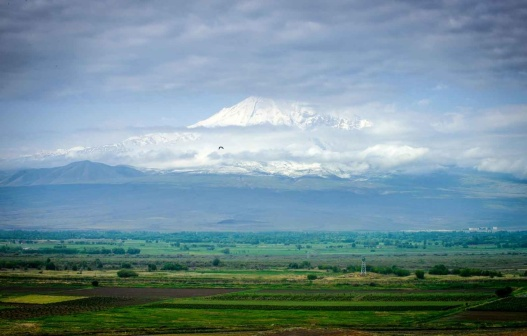How might this landscape change with the seasons? In spring, the snow on the mountain's peak begins to melt, feeding the valley with streams of fresh water, causing the fields to burst into a riot of colorful wildflowers. Summer brings a lush green carpet to the valley, with longer days and an increase in wildlife activities. In autumn, the valley is touched with hues of gold, orange, and red as leaves turn, preparing for the quiet of winter. As the first snows blanket the landscape, the valley turns into a picturesque winter wonderland, with the mountain peak regaining its snowy crown and the cycle beginning anew. 